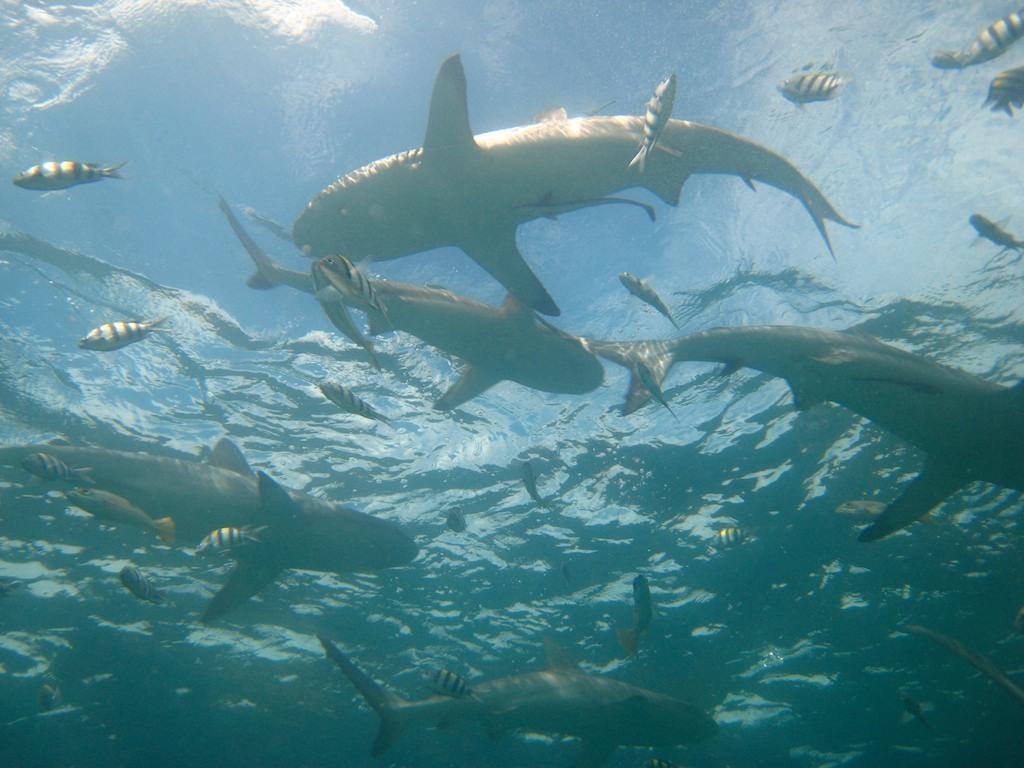Describe this image in one or two sentences. In the image we can see there are many fishes in the water. 